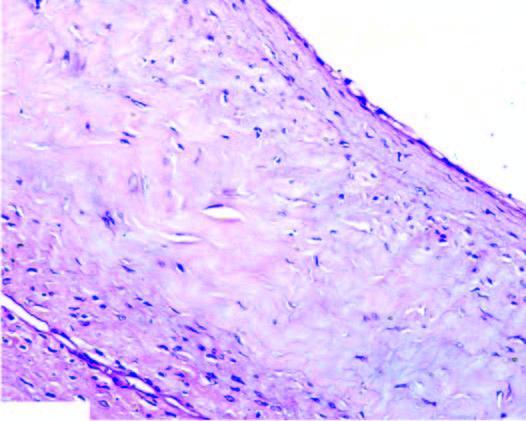does process show myxoid degeneration?
Answer the question using a single word or phrase. No 